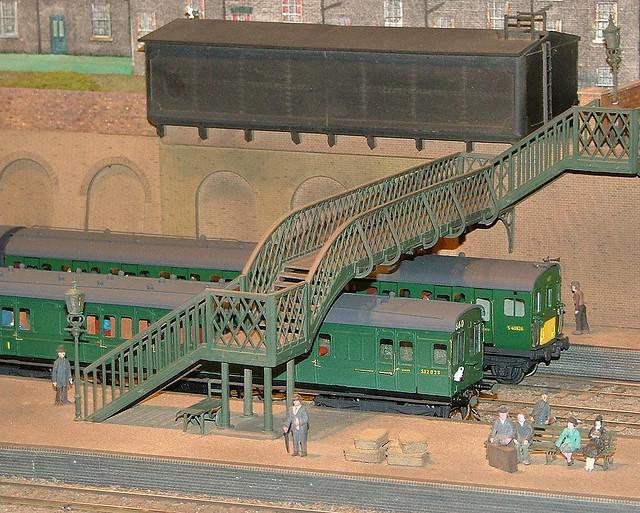What type of trains are shown here? Please explain your reasoning. miniature. There are miniature trains on top of the model track. 